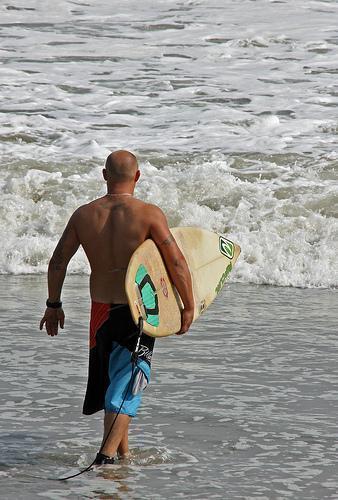How many people are in this photo?
Give a very brief answer. 1. 